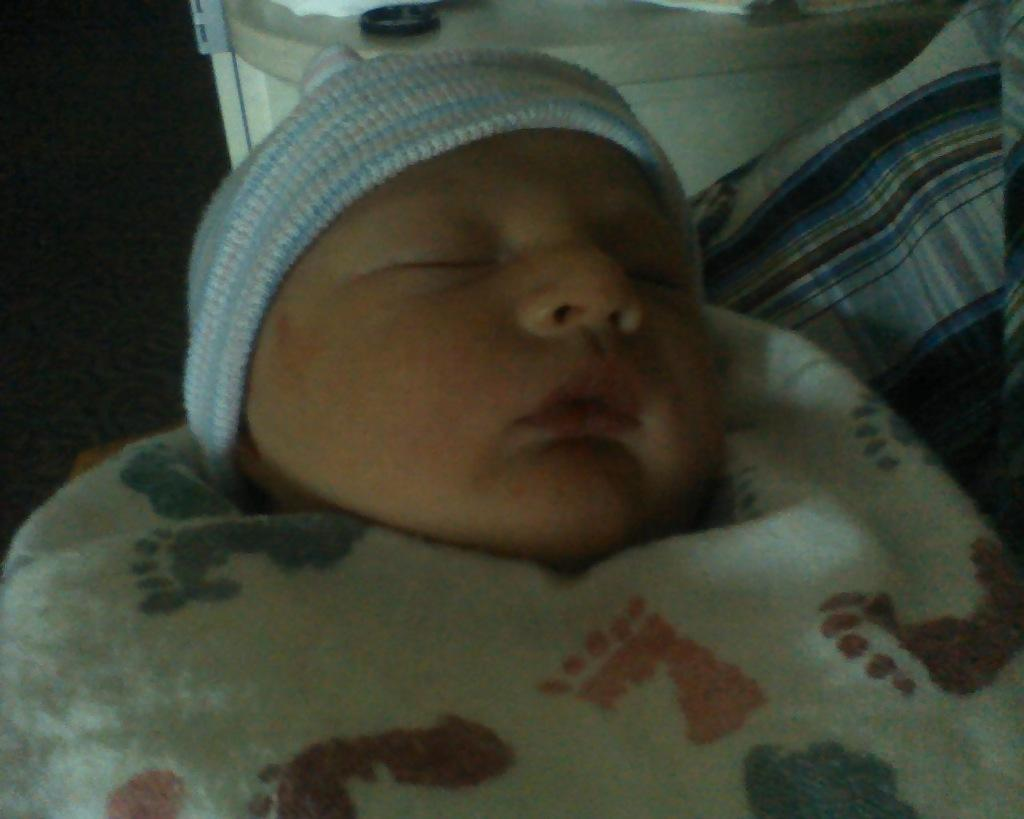What is the main subject of the image? There is a child in the image. What is the child doing in the image? The child is sleeping. Can you describe the background of the image? The background of the image is dark. What month is the child celebrating in the image? There is no indication of a specific month or celebration in the image; the child is simply sleeping. 